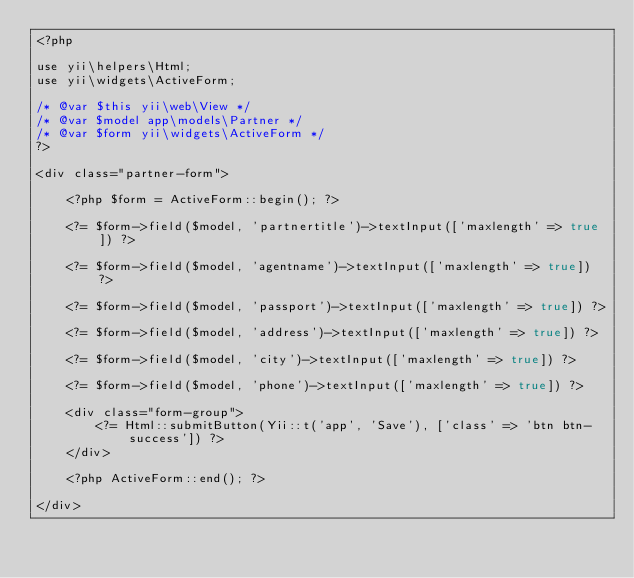<code> <loc_0><loc_0><loc_500><loc_500><_PHP_><?php

use yii\helpers\Html;
use yii\widgets\ActiveForm;

/* @var $this yii\web\View */
/* @var $model app\models\Partner */
/* @var $form yii\widgets\ActiveForm */
?>

<div class="partner-form">

    <?php $form = ActiveForm::begin(); ?>

    <?= $form->field($model, 'partnertitle')->textInput(['maxlength' => true]) ?>

    <?= $form->field($model, 'agentname')->textInput(['maxlength' => true]) ?>

    <?= $form->field($model, 'passport')->textInput(['maxlength' => true]) ?>

    <?= $form->field($model, 'address')->textInput(['maxlength' => true]) ?>

    <?= $form->field($model, 'city')->textInput(['maxlength' => true]) ?>

    <?= $form->field($model, 'phone')->textInput(['maxlength' => true]) ?>

    <div class="form-group">
        <?= Html::submitButton(Yii::t('app', 'Save'), ['class' => 'btn btn-success']) ?>
    </div>

    <?php ActiveForm::end(); ?>

</div>
</code> 